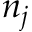Convert formula to latex. <formula><loc_0><loc_0><loc_500><loc_500>n _ { j }</formula> 